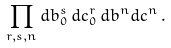<formula> <loc_0><loc_0><loc_500><loc_500>\prod _ { r , s , n } d b _ { 0 } ^ { s } \, d c _ { 0 } ^ { r } \, d b ^ { n } d c ^ { n } \, .</formula> 